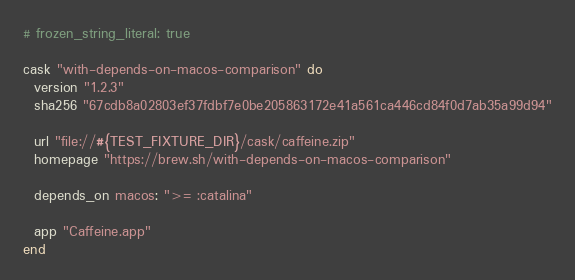Convert code to text. <code><loc_0><loc_0><loc_500><loc_500><_Ruby_># frozen_string_literal: true

cask "with-depends-on-macos-comparison" do
  version "1.2.3"
  sha256 "67cdb8a02803ef37fdbf7e0be205863172e41a561ca446cd84f0d7ab35a99d94"

  url "file://#{TEST_FIXTURE_DIR}/cask/caffeine.zip"
  homepage "https://brew.sh/with-depends-on-macos-comparison"

  depends_on macos: ">= :catalina"

  app "Caffeine.app"
end
</code> 